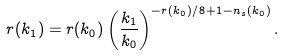<formula> <loc_0><loc_0><loc_500><loc_500>r ( k _ { 1 } ) = r ( k _ { 0 } ) \left ( \frac { k _ { 1 } } { k _ { 0 } } \right ) ^ { - r ( k _ { 0 } ) / 8 + 1 - n _ { s } ( k _ { 0 } ) } .</formula> 